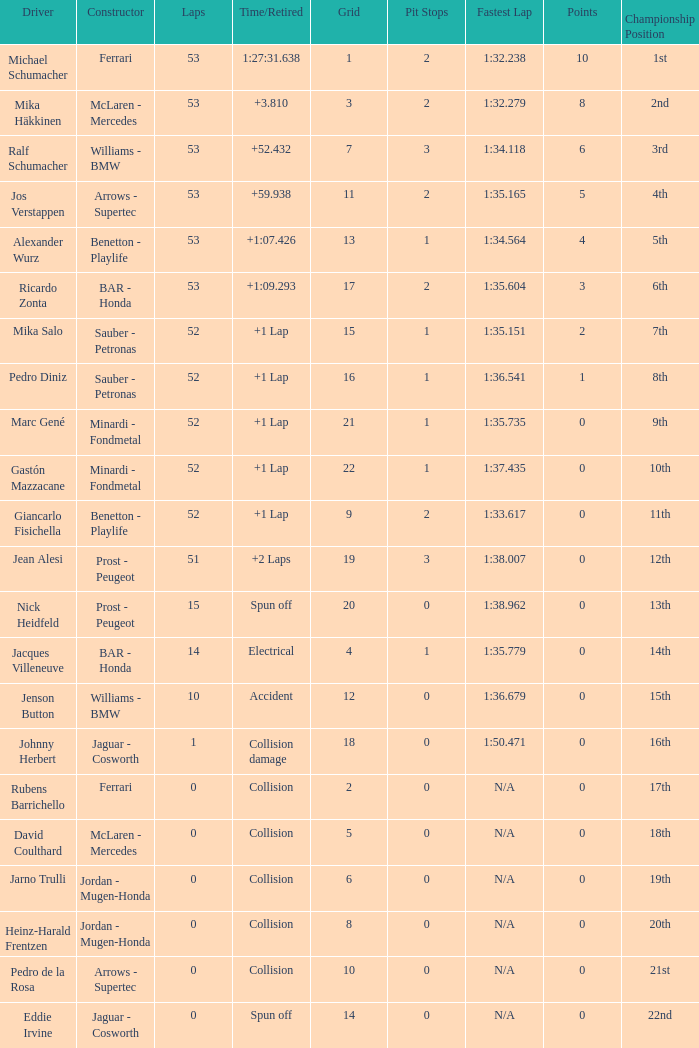How many laps did Ricardo Zonta have? 53.0. 